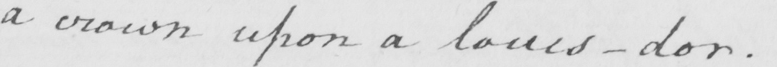Please provide the text content of this handwritten line. a crown upon a louis-dor  . 